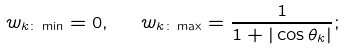Convert formula to latex. <formula><loc_0><loc_0><loc_500><loc_500>w _ { k \colon \min } = 0 , \ \ w _ { k \colon \max } = \frac { 1 } { 1 + | \cos { \theta } _ { k } | } ;</formula> 